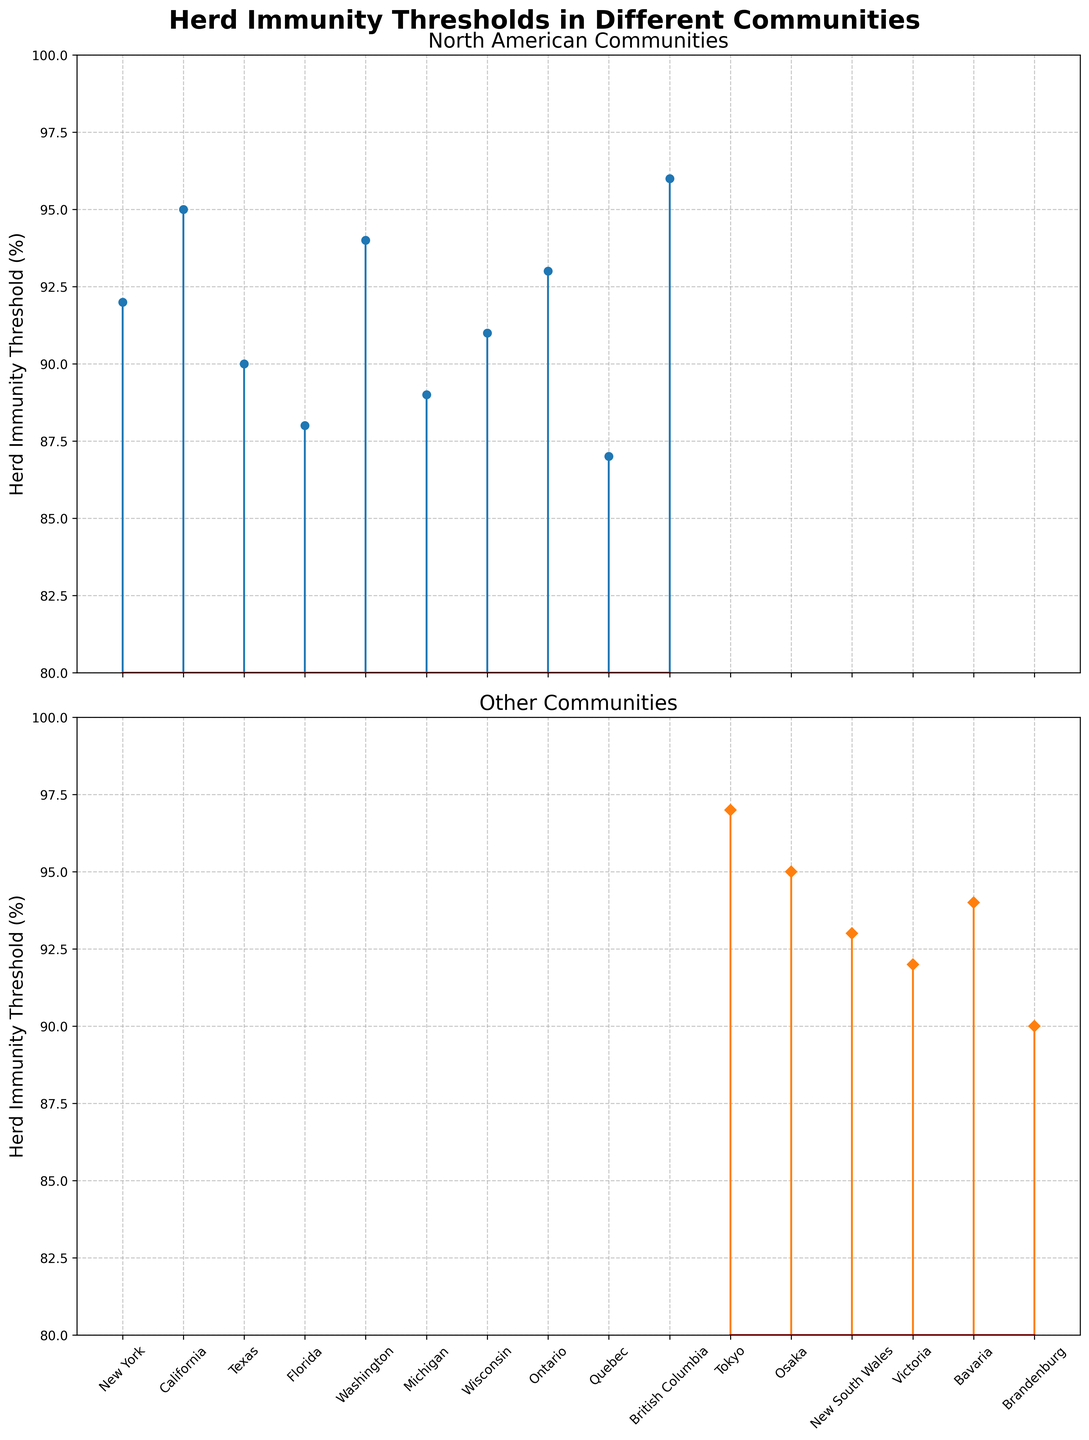What's the title of the chart? The title is written at the top center of the figure. It is "Herd Immunity Thresholds in Different Communities".
Answer: Herd Immunity Thresholds in Different Communities How many North American communities are shown in the first subplot? The North American subplot lists the following communities: New York, California, Texas, Florida, Washington, Michigan, Wisconsin, Ontario, Quebec, and British Columbia. Counting these, there are 10 communities.
Answer: 10 Which community has the highest herd immunity threshold in the second subplot? By comparing the threshold values in the second subplot visually, Tokyo has the highest threshold of 97%.
Answer: Tokyo What is the herd immunity threshold for California? In the North American subplot, the threshold for California is 95%.
Answer: 95% Which community in the first subplot has the lowest herd immunity threshold? Florida shows the lowest value in the North American subplot, with a threshold of 88%.
Answer: Florida Calculate the average herd immunity threshold of the North American communities. The thresholds for North American communities are 92, 95, 90, 88, 94, 89, 91, 93, 87, and 96. Summing these gives 915. Dividing by 10 gives an average of 91.5%.
Answer: 91.5% Compare the herd immunity thresholds of Victoria and Bavaria. Which one is higher? Victoria has a threshold of 92%, and Bavaria has 94%. Therefore, Bavaria's threshold is higher.
Answer: Bavaria What's the minimum herd immunity threshold in the second subplot? In the second subplot, comparing all values, Quebec has the minimum threshold of 87%.
Answer: Quebec Identify the range of herd immunity thresholds in North American communities. The highest threshold in North American communities is 96 (British Columbia), and the lowest is 88 (Florida). The range is 96 - 88 = 8.
Answer: 8 What's the combined total of herd immunity thresholds for the communities in the second subplot? Summing the thresholds for the second subplot communities (Tokyo: 97, Osaka: 95, New South Wales: 93, Victoria: 92, Bavaria: 94, Brandenburg: 90) gives 561.
Answer: 561 